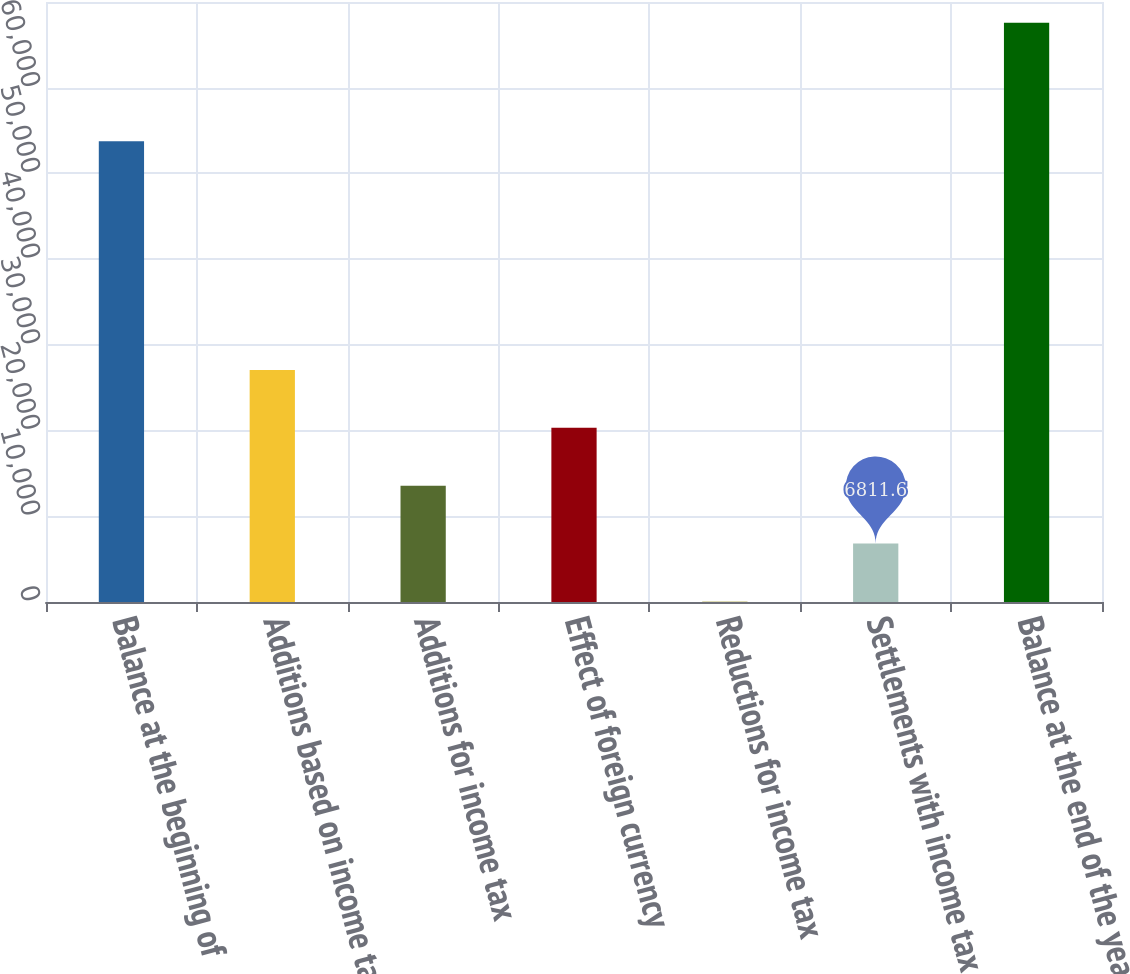Convert chart. <chart><loc_0><loc_0><loc_500><loc_500><bar_chart><fcel>Balance at the beginning of<fcel>Additions based on income tax<fcel>Additions for income tax<fcel>Effect of foreign currency<fcel>Reductions for income tax<fcel>Settlements with income tax<fcel>Balance at the end of the year<nl><fcel>53763<fcel>27066.4<fcel>13563.2<fcel>20314.8<fcel>60<fcel>6811.6<fcel>67576<nl></chart> 